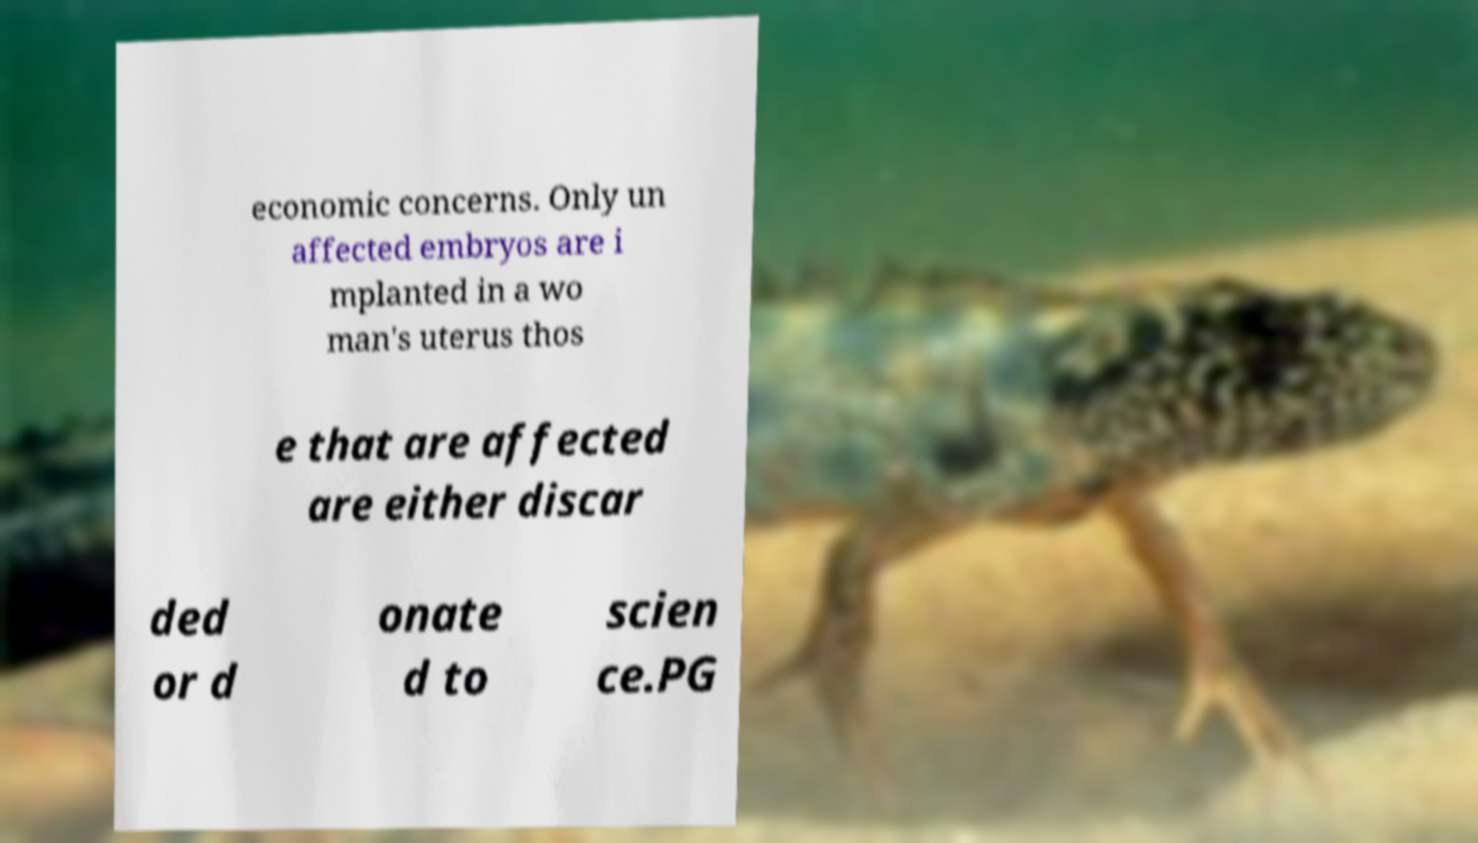Can you read and provide the text displayed in the image?This photo seems to have some interesting text. Can you extract and type it out for me? economic concerns. Only un affected embryos are i mplanted in a wo man's uterus thos e that are affected are either discar ded or d onate d to scien ce.PG 